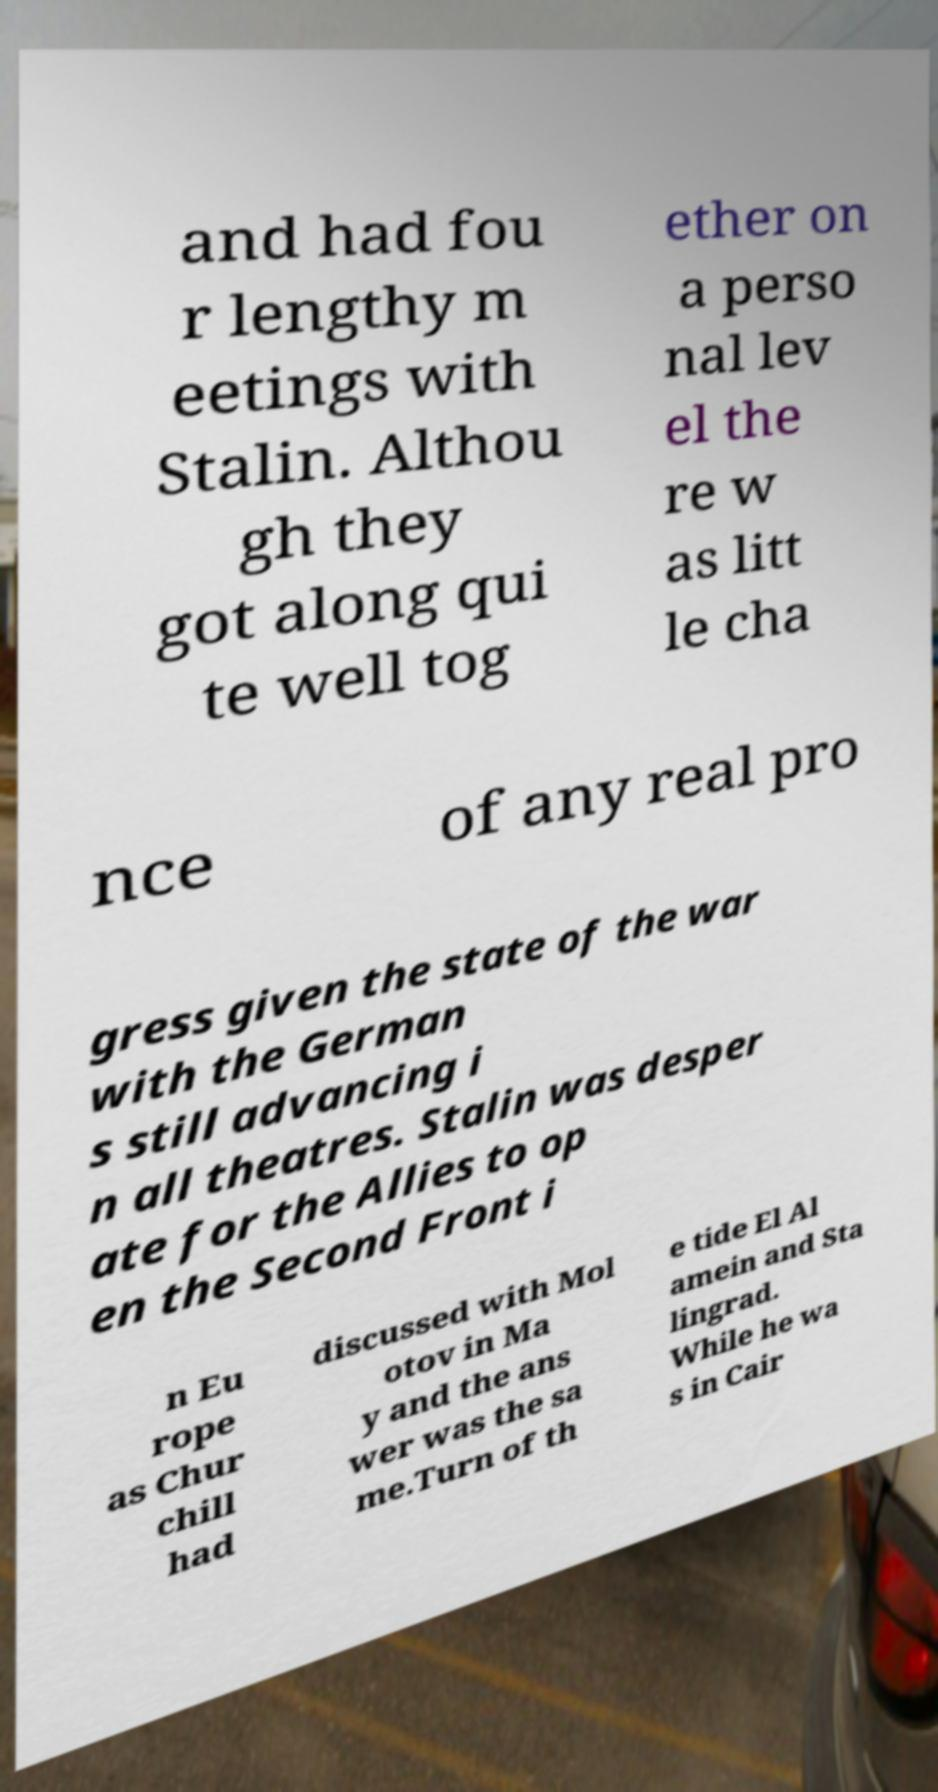Could you assist in decoding the text presented in this image and type it out clearly? and had fou r lengthy m eetings with Stalin. Althou gh they got along qui te well tog ether on a perso nal lev el the re w as litt le cha nce of any real pro gress given the state of the war with the German s still advancing i n all theatres. Stalin was desper ate for the Allies to op en the Second Front i n Eu rope as Chur chill had discussed with Mol otov in Ma y and the ans wer was the sa me.Turn of th e tide El Al amein and Sta lingrad. While he wa s in Cair 